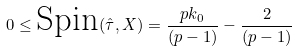<formula> <loc_0><loc_0><loc_500><loc_500>0 \leq \text {Spin} ( \hat { \tau } , X ) = \frac { p k _ { 0 } } { ( p - 1 ) } - \frac { 2 } { ( p - 1 ) }</formula> 